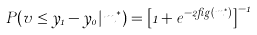Convert formula to latex. <formula><loc_0><loc_0><loc_500><loc_500>P ( v \leq y _ { 1 } - y _ { 0 } | m ^ { * } ) = \left [ 1 + e ^ { - 2 \beta g ( m ^ { * } ) } \right ] ^ { - 1 }</formula> 